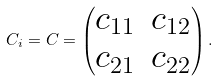Convert formula to latex. <formula><loc_0><loc_0><loc_500><loc_500>C _ { i } = C = \begin{pmatrix} c _ { 1 1 } & c _ { 1 2 } \\ c _ { 2 1 } & c _ { 2 2 } \end{pmatrix} .</formula> 